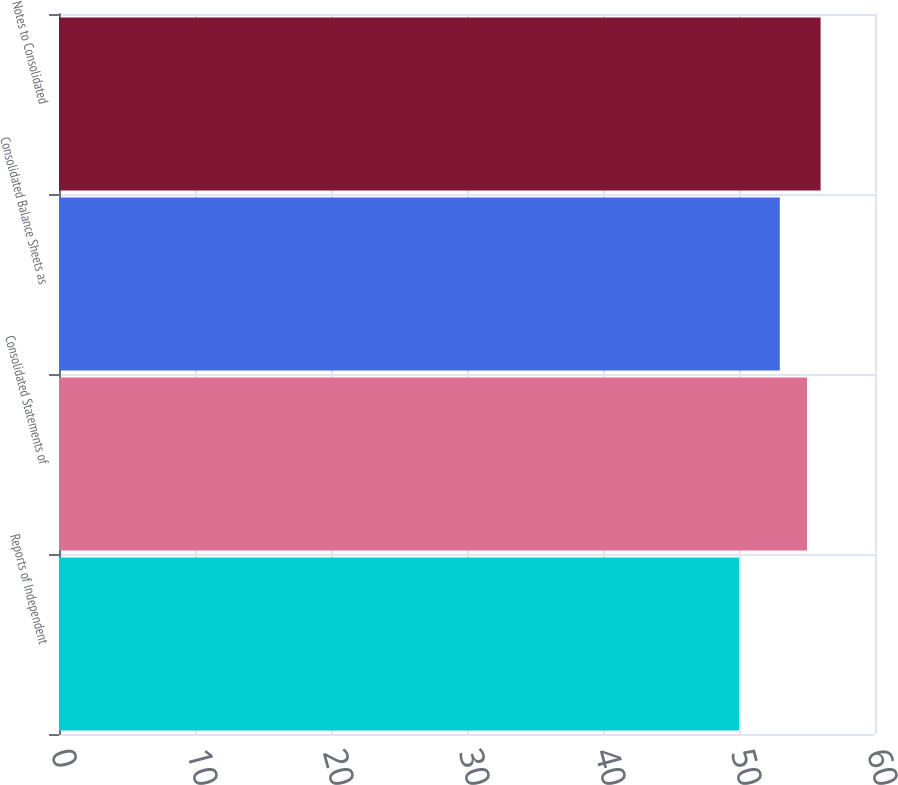<chart> <loc_0><loc_0><loc_500><loc_500><bar_chart><fcel>Reports of Independent<fcel>Consolidated Statements of<fcel>Consolidated Balance Sheets as<fcel>Notes to Consolidated<nl><fcel>50<fcel>55<fcel>53<fcel>56<nl></chart> 